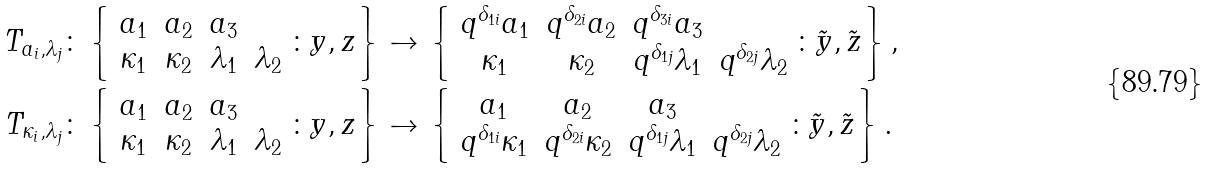<formula> <loc_0><loc_0><loc_500><loc_500>T _ { a _ { i } , \lambda _ { j } } \colon \left \{ \begin{array} { c c c c } a _ { 1 } & a _ { 2 } & a _ { 3 } & \\ \kappa _ { 1 } & \kappa _ { 2 } & \lambda _ { 1 } & \lambda _ { 2 } \end{array} \colon y , z \right \} & \to \left \{ \begin{array} { c c c c } q ^ { \delta _ { 1 i } } a _ { 1 } & q ^ { \delta _ { 2 i } } a _ { 2 } & q ^ { \delta _ { 3 i } } a _ { 3 } \\ \kappa _ { 1 } & \kappa _ { 2 } & q ^ { \delta _ { 1 j } } \lambda _ { 1 } & q ^ { \delta _ { 2 j } } \lambda _ { 2 } \end{array} \colon \tilde { y } , \tilde { z } \right \} , \\ T _ { \kappa _ { i } , \lambda _ { j } } \colon \left \{ \begin{array} { c c c c } a _ { 1 } & a _ { 2 } & a _ { 3 } & \\ \kappa _ { 1 } & \kappa _ { 2 } & \lambda _ { 1 } & \lambda _ { 2 } \end{array} \colon y , z \right \} & \to \left \{ \begin{array} { c c c c } a _ { 1 } & a _ { 2 } & a _ { 3 } & \\ q ^ { \delta _ { 1 i } } \kappa _ { 1 } & q ^ { \delta _ { 2 i } } \kappa _ { 2 } & q ^ { \delta _ { 1 j } } \lambda _ { 1 } & q ^ { \delta _ { 2 j } } \lambda _ { 2 } \end{array} \colon \tilde { y } , \tilde { z } \right \} .</formula> 